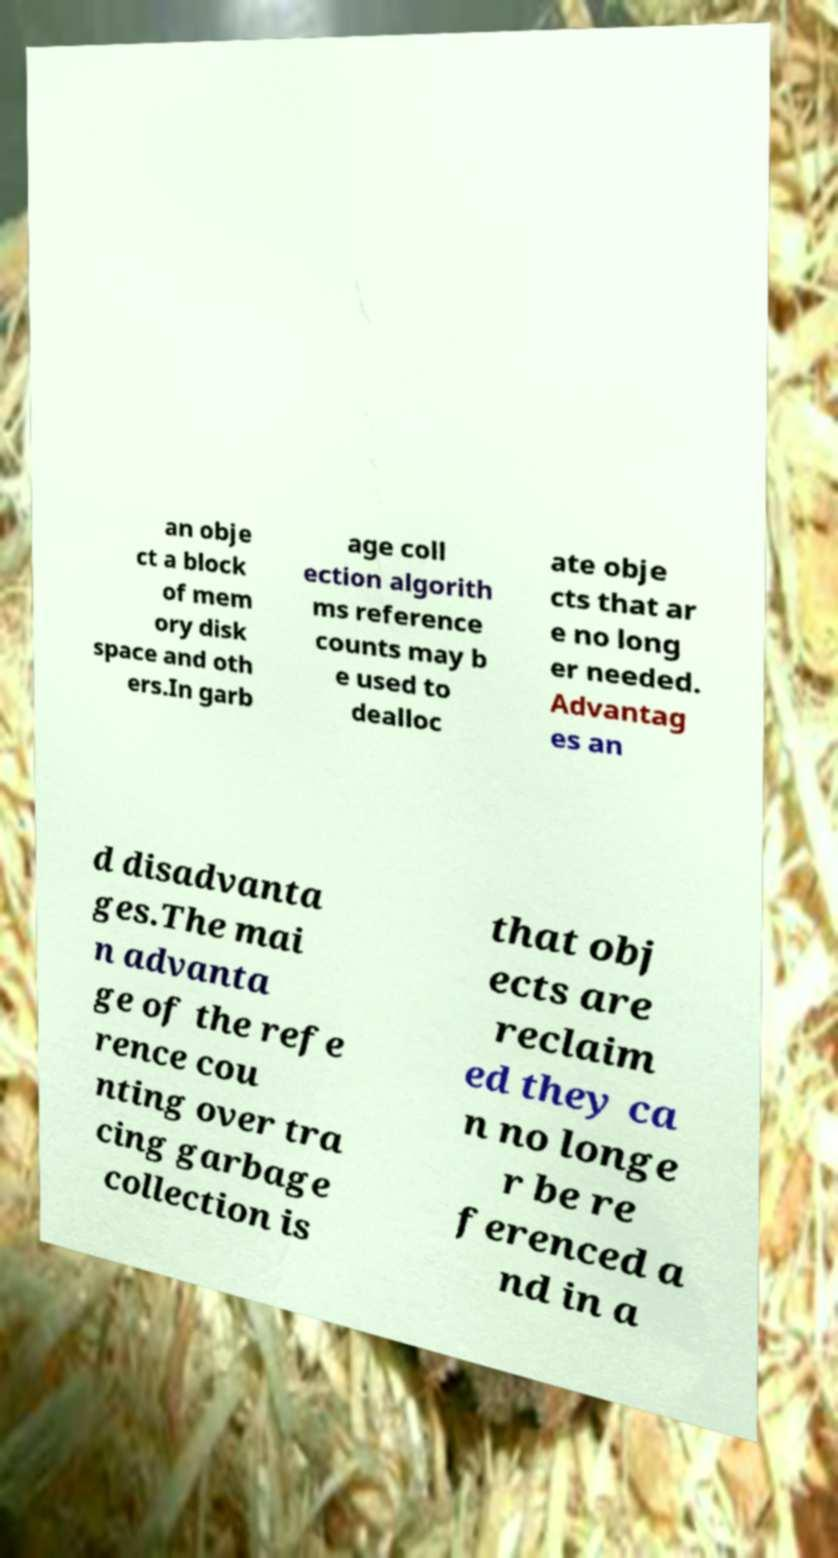For documentation purposes, I need the text within this image transcribed. Could you provide that? an obje ct a block of mem ory disk space and oth ers.In garb age coll ection algorith ms reference counts may b e used to dealloc ate obje cts that ar e no long er needed. Advantag es an d disadvanta ges.The mai n advanta ge of the refe rence cou nting over tra cing garbage collection is that obj ects are reclaim ed they ca n no longe r be re ferenced a nd in a 